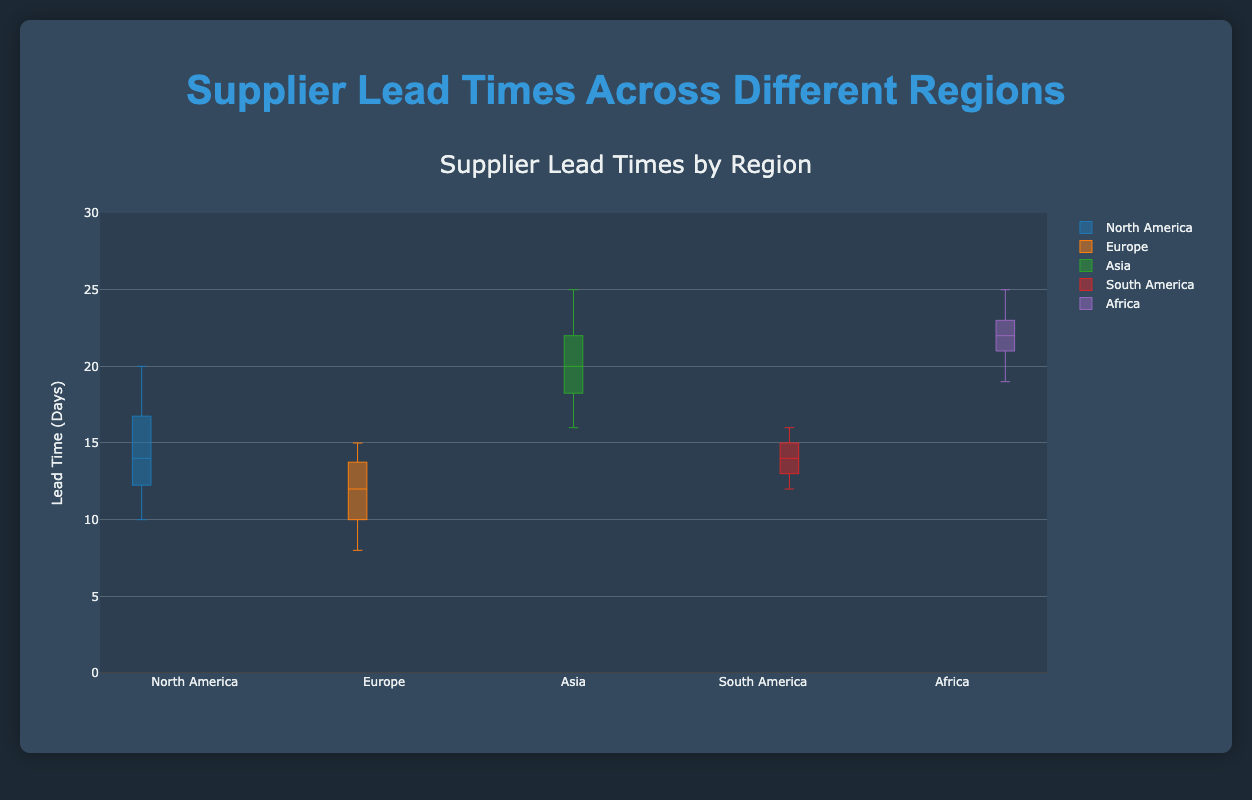What is the title of the plot? The title is displayed prominently at the top of the plot. It indicates what the plot is about.
Answer: Supplier Lead Times by Region What is the unit of measurement on the y-axis? The label on the y-axis specifies the unit of measurement for the data shown in the plot.
Answer: Lead Time (Days) Which region has the highest median lead time? The median of each region can be found at the line in the middle of each box in the box plot.
Answer: Africa Which region has the smallest range of lead times? The range can be found by looking at the distance between the smallest value (bottom whisker) and the largest value (top whisker) of each box plot. Europe has the smallest range.
Answer: Europe How does the interquartile range (IQR) of North America’s lead times compare to that of Asia? The IQR is the range between the first quartile (bottom boundary of the box) and the third quartile (top boundary of the box). Compare the heights of the boxes for North America and Asia.
Answer: North America’s IQR is smaller than Asia’s How many outliers are there in the lead times for Africa? Outliers are represented by individual points outside the whiskers of the box plot. Count those points for Africa.
Answer: 0 Which region has the lowest minimum lead time? The minimum lead time is represented by the bottom whisker. The lowest whisker among all regions belongs to the region with the minimum lead time.
Answer: Europe Which regions have a median lead time greater than 15 days? The median is the central line in each box. Identify the regions where this line is above 15.
Answer: North America, Asia, Africa What is the median lead time for South America? The median value in a box plot is indicated by the line inside the box. Look at the line inside the box for South America.
Answer: 14 days Compare the third quartile (Q3) lead time in Europe with the first quartile (Q1) lead time in Asia. Which is higher? The third quartile (Q3) is the top boundary of the box, and the first quartile (Q1) is the bottom boundary of the box. Compare Q3 in Europe with Q1 in Asia.
Answer: Q1 in Asia is higher 